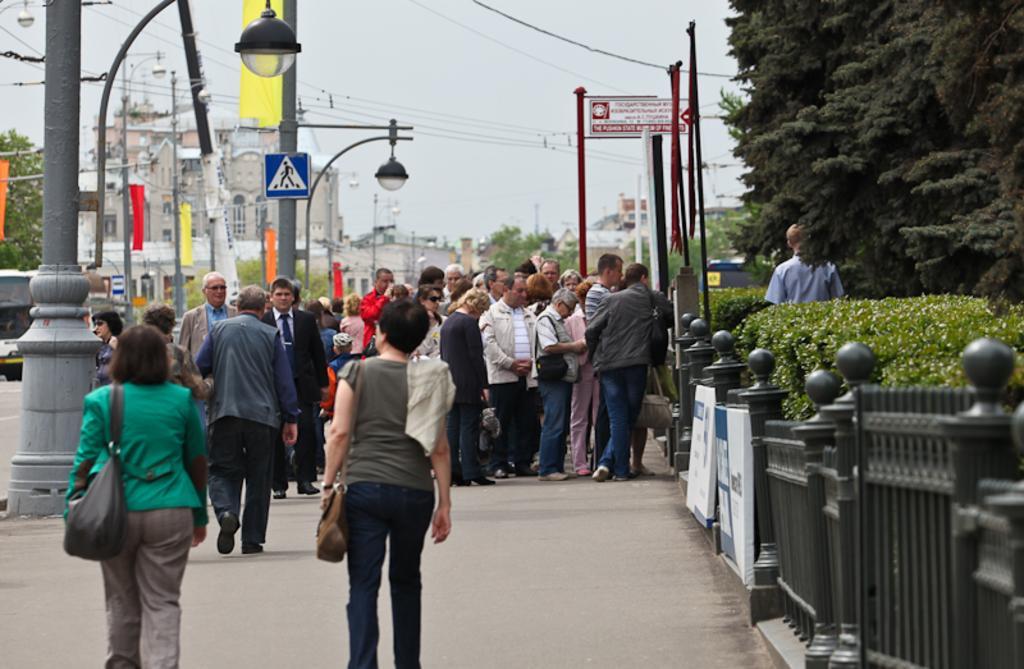How would you summarize this image in a sentence or two? In this picture we can see a group of people where some are standing and three are walking on the road, flags, trees, buildings, fence and in the background we can see the sky. 